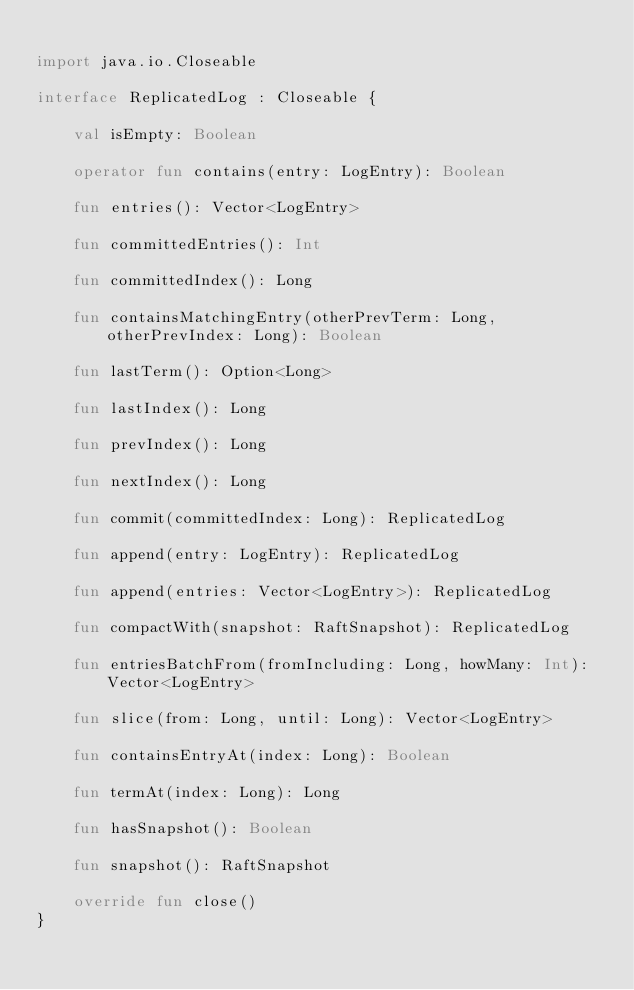Convert code to text. <code><loc_0><loc_0><loc_500><loc_500><_Kotlin_>
import java.io.Closeable

interface ReplicatedLog : Closeable {

    val isEmpty: Boolean

    operator fun contains(entry: LogEntry): Boolean

    fun entries(): Vector<LogEntry>

    fun committedEntries(): Int

    fun committedIndex(): Long

    fun containsMatchingEntry(otherPrevTerm: Long, otherPrevIndex: Long): Boolean

    fun lastTerm(): Option<Long>

    fun lastIndex(): Long

    fun prevIndex(): Long

    fun nextIndex(): Long

    fun commit(committedIndex: Long): ReplicatedLog

    fun append(entry: LogEntry): ReplicatedLog

    fun append(entries: Vector<LogEntry>): ReplicatedLog

    fun compactWith(snapshot: RaftSnapshot): ReplicatedLog

    fun entriesBatchFrom(fromIncluding: Long, howMany: Int): Vector<LogEntry>

    fun slice(from: Long, until: Long): Vector<LogEntry>

    fun containsEntryAt(index: Long): Boolean

    fun termAt(index: Long): Long

    fun hasSnapshot(): Boolean

    fun snapshot(): RaftSnapshot

    override fun close()
}
</code> 